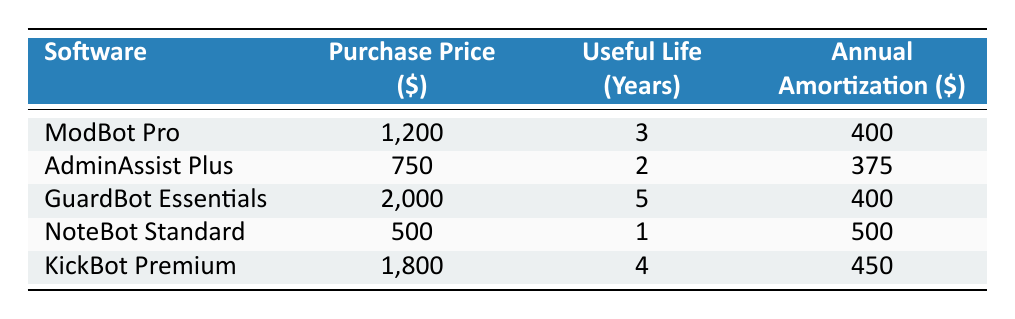What is the purchase price of NoteBot Standard? The purchase price is directly listed in the table under the relevant row. For NoteBot Standard, the value is $500.
Answer: 500 Which software has the highest annual amortization? To find this, I will compare the 'Annual Amortization' values in each row. The highest value is $500 for NoteBot Standard.
Answer: NoteBot Standard What is the total annual amortization for all software licenses? I will sum the annual amortization values of all software licenses: 400 (ModBot Pro) + 375 (AdminAssist Plus) + 400 (GuardBot Essentials) + 500 (NoteBot Standard) + 450 (KickBot Premium) = 2125.
Answer: 2125 Is the useful life of KickBot Premium greater than 3 years? For this question, we look at the 'Useful Life (Years)' column for KickBot Premium. The value is 4 years, which is greater than 3 years.
Answer: Yes What is the average purchase price of the software licenses? To find the average, I will first sum the purchase prices: 1200 (ModBot Pro) + 750 (AdminAssist Plus) + 2000 (GuardBot Essentials) + 500 (NoteBot Standard) + 1800 (KickBot Premium) = 5250. Then, divide by the number of licenses (5): 5250 / 5 = 1050.
Answer: 1050 Which software has the lowest useful life, and what is that life? I will check the 'Useful Life (Years)' column to find the lowest value. The minimum is 1 year for NoteBot Standard.
Answer: NoteBot Standard, 1 year If we add the useful life of ModBot Pro and GuardBot Essentials, what will it be? The useful life for ModBot Pro is 3 years, and for GuardBot Essentials, it is 5 years. I will add these values: 3 + 5 = 8 years.
Answer: 8 years Does AdminAssist Plus have a higher annual amortization than ModBot Pro? Comparing the 'Annual Amortization' values: AdminAssist Plus is 375, and ModBot Pro is 400. Since 375 is less than 400, the statement is false.
Answer: No 